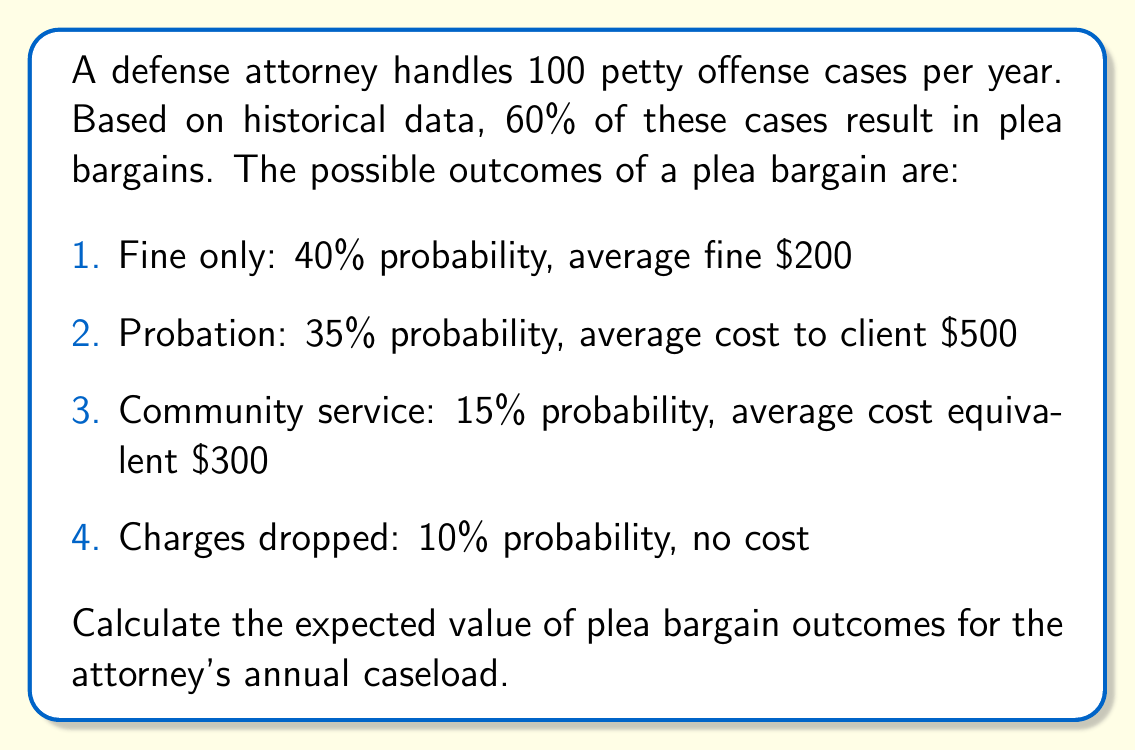Teach me how to tackle this problem. To solve this problem, we need to follow these steps:

1. Calculate the expected value of a single plea bargain outcome
2. Determine the number of cases that result in plea bargains annually
3. Compute the total expected value for the annual caseload

Step 1: Expected value of a single plea bargain outcome

The expected value is calculated by multiplying each possible outcome by its probability and summing the results.

$$E(\text{single plea bargain}) = 0.40 \cdot 200 + 0.35 \cdot 500 + 0.15 \cdot 300 + 0.10 \cdot 0$$

$$E(\text{single plea bargain}) = 80 + 175 + 45 + 0 = 300$$

Step 2: Number of cases resulting in plea bargains annually

Given that 60% of cases result in plea bargains:

$$\text{Number of plea bargains} = 100 \cdot 0.60 = 60 \text{ cases}$$

Step 3: Total expected value for annual caseload

Multiply the expected value of a single plea bargain by the number of plea bargains:

$$E(\text{annual caseload}) = E(\text{single plea bargain}) \cdot \text{Number of plea bargains}$$

$$E(\text{annual caseload}) = 300 \cdot 60 = 18,000$$

Therefore, the expected value of plea bargain outcomes for the attorney's annual caseload is $18,000.
Answer: $18,000 